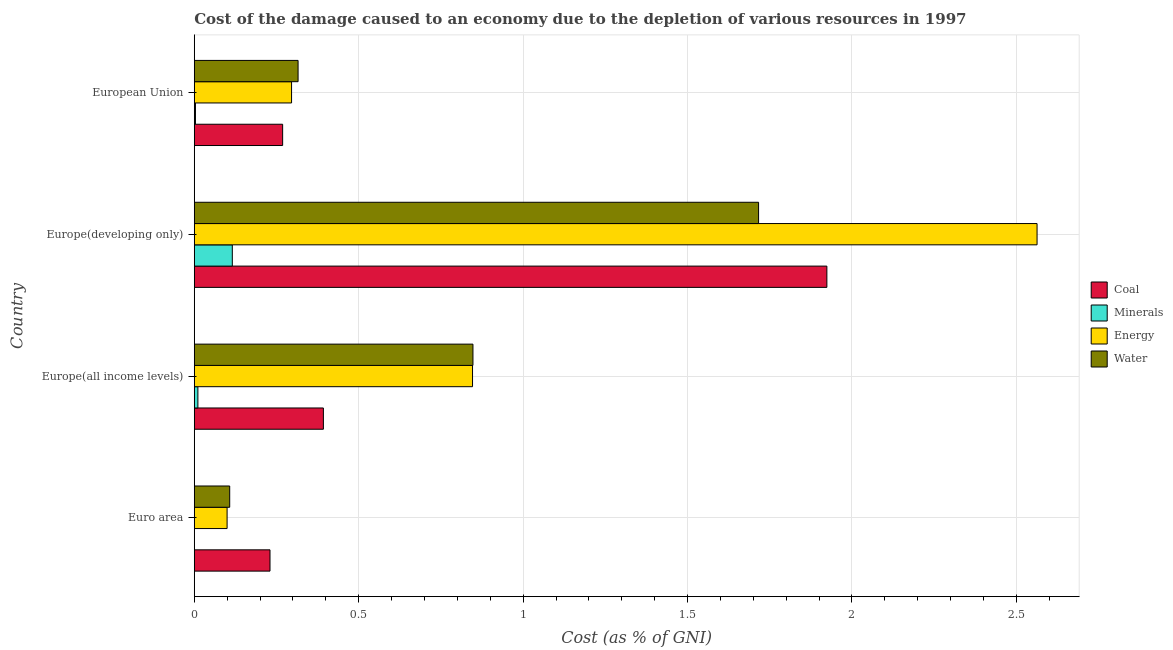How many bars are there on the 4th tick from the bottom?
Offer a terse response. 4. What is the label of the 1st group of bars from the top?
Give a very brief answer. European Union. What is the cost of damage due to depletion of water in Euro area?
Ensure brevity in your answer.  0.11. Across all countries, what is the maximum cost of damage due to depletion of energy?
Make the answer very short. 2.56. Across all countries, what is the minimum cost of damage due to depletion of coal?
Offer a very short reply. 0.23. In which country was the cost of damage due to depletion of energy maximum?
Make the answer very short. Europe(developing only). In which country was the cost of damage due to depletion of minerals minimum?
Your response must be concise. Euro area. What is the total cost of damage due to depletion of minerals in the graph?
Your answer should be very brief. 0.13. What is the difference between the cost of damage due to depletion of energy in Europe(developing only) and that in European Union?
Provide a short and direct response. 2.27. What is the difference between the cost of damage due to depletion of water in Euro area and the cost of damage due to depletion of coal in Europe(all income levels)?
Provide a short and direct response. -0.28. What is the average cost of damage due to depletion of coal per country?
Offer a terse response. 0.7. What is the difference between the cost of damage due to depletion of water and cost of damage due to depletion of coal in Europe(all income levels)?
Offer a terse response. 0.46. In how many countries, is the cost of damage due to depletion of water greater than 1.9 %?
Your answer should be very brief. 0. What is the ratio of the cost of damage due to depletion of water in Euro area to that in European Union?
Offer a terse response. 0.34. Is the difference between the cost of damage due to depletion of coal in Euro area and European Union greater than the difference between the cost of damage due to depletion of water in Euro area and European Union?
Keep it short and to the point. Yes. What is the difference between the highest and the second highest cost of damage due to depletion of water?
Provide a succinct answer. 0.87. What is the difference between the highest and the lowest cost of damage due to depletion of coal?
Offer a very short reply. 1.69. What does the 1st bar from the top in Europe(all income levels) represents?
Offer a very short reply. Water. What does the 1st bar from the bottom in European Union represents?
Provide a short and direct response. Coal. How many bars are there?
Give a very brief answer. 16. Are the values on the major ticks of X-axis written in scientific E-notation?
Provide a short and direct response. No. Does the graph contain any zero values?
Offer a terse response. No. How many legend labels are there?
Your answer should be very brief. 4. How are the legend labels stacked?
Give a very brief answer. Vertical. What is the title of the graph?
Your answer should be compact. Cost of the damage caused to an economy due to the depletion of various resources in 1997 . What is the label or title of the X-axis?
Your response must be concise. Cost (as % of GNI). What is the label or title of the Y-axis?
Provide a short and direct response. Country. What is the Cost (as % of GNI) of Coal in Euro area?
Give a very brief answer. 0.23. What is the Cost (as % of GNI) in Minerals in Euro area?
Keep it short and to the point. 0. What is the Cost (as % of GNI) of Energy in Euro area?
Make the answer very short. 0.1. What is the Cost (as % of GNI) of Water in Euro area?
Provide a short and direct response. 0.11. What is the Cost (as % of GNI) in Coal in Europe(all income levels)?
Provide a short and direct response. 0.39. What is the Cost (as % of GNI) of Minerals in Europe(all income levels)?
Provide a succinct answer. 0.01. What is the Cost (as % of GNI) in Energy in Europe(all income levels)?
Provide a short and direct response. 0.85. What is the Cost (as % of GNI) of Water in Europe(all income levels)?
Keep it short and to the point. 0.85. What is the Cost (as % of GNI) of Coal in Europe(developing only)?
Offer a terse response. 1.92. What is the Cost (as % of GNI) of Minerals in Europe(developing only)?
Provide a short and direct response. 0.12. What is the Cost (as % of GNI) in Energy in Europe(developing only)?
Offer a very short reply. 2.56. What is the Cost (as % of GNI) in Water in Europe(developing only)?
Your answer should be compact. 1.72. What is the Cost (as % of GNI) of Coal in European Union?
Your answer should be compact. 0.27. What is the Cost (as % of GNI) in Minerals in European Union?
Provide a short and direct response. 0. What is the Cost (as % of GNI) in Energy in European Union?
Offer a terse response. 0.3. What is the Cost (as % of GNI) in Water in European Union?
Provide a short and direct response. 0.32. Across all countries, what is the maximum Cost (as % of GNI) in Coal?
Your response must be concise. 1.92. Across all countries, what is the maximum Cost (as % of GNI) in Minerals?
Make the answer very short. 0.12. Across all countries, what is the maximum Cost (as % of GNI) of Energy?
Your answer should be compact. 2.56. Across all countries, what is the maximum Cost (as % of GNI) of Water?
Keep it short and to the point. 1.72. Across all countries, what is the minimum Cost (as % of GNI) in Coal?
Offer a very short reply. 0.23. Across all countries, what is the minimum Cost (as % of GNI) of Minerals?
Your answer should be compact. 0. Across all countries, what is the minimum Cost (as % of GNI) of Energy?
Keep it short and to the point. 0.1. Across all countries, what is the minimum Cost (as % of GNI) in Water?
Offer a very short reply. 0.11. What is the total Cost (as % of GNI) in Coal in the graph?
Your response must be concise. 2.82. What is the total Cost (as % of GNI) of Minerals in the graph?
Keep it short and to the point. 0.13. What is the total Cost (as % of GNI) in Energy in the graph?
Give a very brief answer. 3.8. What is the total Cost (as % of GNI) in Water in the graph?
Provide a short and direct response. 2.99. What is the difference between the Cost (as % of GNI) of Coal in Euro area and that in Europe(all income levels)?
Offer a very short reply. -0.16. What is the difference between the Cost (as % of GNI) in Minerals in Euro area and that in Europe(all income levels)?
Offer a terse response. -0.01. What is the difference between the Cost (as % of GNI) in Energy in Euro area and that in Europe(all income levels)?
Offer a terse response. -0.75. What is the difference between the Cost (as % of GNI) of Water in Euro area and that in Europe(all income levels)?
Your response must be concise. -0.74. What is the difference between the Cost (as % of GNI) of Coal in Euro area and that in Europe(developing only)?
Ensure brevity in your answer.  -1.69. What is the difference between the Cost (as % of GNI) of Minerals in Euro area and that in Europe(developing only)?
Give a very brief answer. -0.12. What is the difference between the Cost (as % of GNI) of Energy in Euro area and that in Europe(developing only)?
Keep it short and to the point. -2.46. What is the difference between the Cost (as % of GNI) in Water in Euro area and that in Europe(developing only)?
Your answer should be compact. -1.61. What is the difference between the Cost (as % of GNI) of Coal in Euro area and that in European Union?
Provide a succinct answer. -0.04. What is the difference between the Cost (as % of GNI) of Minerals in Euro area and that in European Union?
Provide a succinct answer. -0. What is the difference between the Cost (as % of GNI) in Energy in Euro area and that in European Union?
Offer a terse response. -0.2. What is the difference between the Cost (as % of GNI) of Water in Euro area and that in European Union?
Ensure brevity in your answer.  -0.21. What is the difference between the Cost (as % of GNI) of Coal in Europe(all income levels) and that in Europe(developing only)?
Your response must be concise. -1.53. What is the difference between the Cost (as % of GNI) of Minerals in Europe(all income levels) and that in Europe(developing only)?
Your answer should be compact. -0.1. What is the difference between the Cost (as % of GNI) of Energy in Europe(all income levels) and that in Europe(developing only)?
Your response must be concise. -1.72. What is the difference between the Cost (as % of GNI) in Water in Europe(all income levels) and that in Europe(developing only)?
Make the answer very short. -0.87. What is the difference between the Cost (as % of GNI) in Coal in Europe(all income levels) and that in European Union?
Offer a very short reply. 0.12. What is the difference between the Cost (as % of GNI) of Minerals in Europe(all income levels) and that in European Union?
Your response must be concise. 0.01. What is the difference between the Cost (as % of GNI) in Energy in Europe(all income levels) and that in European Union?
Your answer should be very brief. 0.55. What is the difference between the Cost (as % of GNI) in Water in Europe(all income levels) and that in European Union?
Ensure brevity in your answer.  0.53. What is the difference between the Cost (as % of GNI) of Coal in Europe(developing only) and that in European Union?
Your response must be concise. 1.66. What is the difference between the Cost (as % of GNI) in Minerals in Europe(developing only) and that in European Union?
Your answer should be very brief. 0.11. What is the difference between the Cost (as % of GNI) of Energy in Europe(developing only) and that in European Union?
Your answer should be compact. 2.27. What is the difference between the Cost (as % of GNI) of Water in Europe(developing only) and that in European Union?
Give a very brief answer. 1.4. What is the difference between the Cost (as % of GNI) in Coal in Euro area and the Cost (as % of GNI) in Minerals in Europe(all income levels)?
Give a very brief answer. 0.22. What is the difference between the Cost (as % of GNI) in Coal in Euro area and the Cost (as % of GNI) in Energy in Europe(all income levels)?
Your answer should be very brief. -0.62. What is the difference between the Cost (as % of GNI) of Coal in Euro area and the Cost (as % of GNI) of Water in Europe(all income levels)?
Make the answer very short. -0.62. What is the difference between the Cost (as % of GNI) in Minerals in Euro area and the Cost (as % of GNI) in Energy in Europe(all income levels)?
Your response must be concise. -0.85. What is the difference between the Cost (as % of GNI) of Minerals in Euro area and the Cost (as % of GNI) of Water in Europe(all income levels)?
Make the answer very short. -0.85. What is the difference between the Cost (as % of GNI) of Energy in Euro area and the Cost (as % of GNI) of Water in Europe(all income levels)?
Provide a succinct answer. -0.75. What is the difference between the Cost (as % of GNI) of Coal in Euro area and the Cost (as % of GNI) of Minerals in Europe(developing only)?
Your answer should be very brief. 0.11. What is the difference between the Cost (as % of GNI) in Coal in Euro area and the Cost (as % of GNI) in Energy in Europe(developing only)?
Provide a succinct answer. -2.33. What is the difference between the Cost (as % of GNI) in Coal in Euro area and the Cost (as % of GNI) in Water in Europe(developing only)?
Offer a very short reply. -1.49. What is the difference between the Cost (as % of GNI) in Minerals in Euro area and the Cost (as % of GNI) in Energy in Europe(developing only)?
Offer a very short reply. -2.56. What is the difference between the Cost (as % of GNI) of Minerals in Euro area and the Cost (as % of GNI) of Water in Europe(developing only)?
Your response must be concise. -1.72. What is the difference between the Cost (as % of GNI) in Energy in Euro area and the Cost (as % of GNI) in Water in Europe(developing only)?
Give a very brief answer. -1.62. What is the difference between the Cost (as % of GNI) of Coal in Euro area and the Cost (as % of GNI) of Minerals in European Union?
Give a very brief answer. 0.23. What is the difference between the Cost (as % of GNI) in Coal in Euro area and the Cost (as % of GNI) in Energy in European Union?
Your answer should be compact. -0.07. What is the difference between the Cost (as % of GNI) in Coal in Euro area and the Cost (as % of GNI) in Water in European Union?
Offer a terse response. -0.09. What is the difference between the Cost (as % of GNI) of Minerals in Euro area and the Cost (as % of GNI) of Energy in European Union?
Ensure brevity in your answer.  -0.3. What is the difference between the Cost (as % of GNI) of Minerals in Euro area and the Cost (as % of GNI) of Water in European Union?
Provide a succinct answer. -0.32. What is the difference between the Cost (as % of GNI) of Energy in Euro area and the Cost (as % of GNI) of Water in European Union?
Keep it short and to the point. -0.22. What is the difference between the Cost (as % of GNI) in Coal in Europe(all income levels) and the Cost (as % of GNI) in Minerals in Europe(developing only)?
Offer a terse response. 0.28. What is the difference between the Cost (as % of GNI) in Coal in Europe(all income levels) and the Cost (as % of GNI) in Energy in Europe(developing only)?
Keep it short and to the point. -2.17. What is the difference between the Cost (as % of GNI) in Coal in Europe(all income levels) and the Cost (as % of GNI) in Water in Europe(developing only)?
Make the answer very short. -1.32. What is the difference between the Cost (as % of GNI) in Minerals in Europe(all income levels) and the Cost (as % of GNI) in Energy in Europe(developing only)?
Offer a very short reply. -2.55. What is the difference between the Cost (as % of GNI) of Minerals in Europe(all income levels) and the Cost (as % of GNI) of Water in Europe(developing only)?
Ensure brevity in your answer.  -1.71. What is the difference between the Cost (as % of GNI) in Energy in Europe(all income levels) and the Cost (as % of GNI) in Water in Europe(developing only)?
Offer a very short reply. -0.87. What is the difference between the Cost (as % of GNI) in Coal in Europe(all income levels) and the Cost (as % of GNI) in Minerals in European Union?
Give a very brief answer. 0.39. What is the difference between the Cost (as % of GNI) in Coal in Europe(all income levels) and the Cost (as % of GNI) in Energy in European Union?
Offer a very short reply. 0.1. What is the difference between the Cost (as % of GNI) of Coal in Europe(all income levels) and the Cost (as % of GNI) of Water in European Union?
Provide a succinct answer. 0.08. What is the difference between the Cost (as % of GNI) of Minerals in Europe(all income levels) and the Cost (as % of GNI) of Energy in European Union?
Make the answer very short. -0.28. What is the difference between the Cost (as % of GNI) of Minerals in Europe(all income levels) and the Cost (as % of GNI) of Water in European Union?
Keep it short and to the point. -0.3. What is the difference between the Cost (as % of GNI) in Energy in Europe(all income levels) and the Cost (as % of GNI) in Water in European Union?
Keep it short and to the point. 0.53. What is the difference between the Cost (as % of GNI) in Coal in Europe(developing only) and the Cost (as % of GNI) in Minerals in European Union?
Ensure brevity in your answer.  1.92. What is the difference between the Cost (as % of GNI) of Coal in Europe(developing only) and the Cost (as % of GNI) of Energy in European Union?
Provide a succinct answer. 1.63. What is the difference between the Cost (as % of GNI) in Coal in Europe(developing only) and the Cost (as % of GNI) in Water in European Union?
Your response must be concise. 1.61. What is the difference between the Cost (as % of GNI) of Minerals in Europe(developing only) and the Cost (as % of GNI) of Energy in European Union?
Your response must be concise. -0.18. What is the difference between the Cost (as % of GNI) in Minerals in Europe(developing only) and the Cost (as % of GNI) in Water in European Union?
Give a very brief answer. -0.2. What is the difference between the Cost (as % of GNI) in Energy in Europe(developing only) and the Cost (as % of GNI) in Water in European Union?
Ensure brevity in your answer.  2.25. What is the average Cost (as % of GNI) in Coal per country?
Offer a very short reply. 0.7. What is the average Cost (as % of GNI) of Minerals per country?
Ensure brevity in your answer.  0.03. What is the average Cost (as % of GNI) in Energy per country?
Give a very brief answer. 0.95. What is the average Cost (as % of GNI) in Water per country?
Keep it short and to the point. 0.75. What is the difference between the Cost (as % of GNI) of Coal and Cost (as % of GNI) of Minerals in Euro area?
Your response must be concise. 0.23. What is the difference between the Cost (as % of GNI) of Coal and Cost (as % of GNI) of Energy in Euro area?
Ensure brevity in your answer.  0.13. What is the difference between the Cost (as % of GNI) in Coal and Cost (as % of GNI) in Water in Euro area?
Offer a very short reply. 0.12. What is the difference between the Cost (as % of GNI) of Minerals and Cost (as % of GNI) of Energy in Euro area?
Your answer should be compact. -0.1. What is the difference between the Cost (as % of GNI) of Minerals and Cost (as % of GNI) of Water in Euro area?
Your response must be concise. -0.11. What is the difference between the Cost (as % of GNI) in Energy and Cost (as % of GNI) in Water in Euro area?
Offer a terse response. -0.01. What is the difference between the Cost (as % of GNI) in Coal and Cost (as % of GNI) in Minerals in Europe(all income levels)?
Give a very brief answer. 0.38. What is the difference between the Cost (as % of GNI) in Coal and Cost (as % of GNI) in Energy in Europe(all income levels)?
Your answer should be very brief. -0.45. What is the difference between the Cost (as % of GNI) of Coal and Cost (as % of GNI) of Water in Europe(all income levels)?
Ensure brevity in your answer.  -0.45. What is the difference between the Cost (as % of GNI) in Minerals and Cost (as % of GNI) in Energy in Europe(all income levels)?
Your answer should be very brief. -0.84. What is the difference between the Cost (as % of GNI) in Minerals and Cost (as % of GNI) in Water in Europe(all income levels)?
Provide a succinct answer. -0.84. What is the difference between the Cost (as % of GNI) of Energy and Cost (as % of GNI) of Water in Europe(all income levels)?
Give a very brief answer. -0. What is the difference between the Cost (as % of GNI) in Coal and Cost (as % of GNI) in Minerals in Europe(developing only)?
Your answer should be compact. 1.81. What is the difference between the Cost (as % of GNI) of Coal and Cost (as % of GNI) of Energy in Europe(developing only)?
Your response must be concise. -0.64. What is the difference between the Cost (as % of GNI) in Coal and Cost (as % of GNI) in Water in Europe(developing only)?
Your answer should be very brief. 0.21. What is the difference between the Cost (as % of GNI) in Minerals and Cost (as % of GNI) in Energy in Europe(developing only)?
Provide a succinct answer. -2.45. What is the difference between the Cost (as % of GNI) in Minerals and Cost (as % of GNI) in Water in Europe(developing only)?
Your answer should be compact. -1.6. What is the difference between the Cost (as % of GNI) in Energy and Cost (as % of GNI) in Water in Europe(developing only)?
Provide a succinct answer. 0.85. What is the difference between the Cost (as % of GNI) of Coal and Cost (as % of GNI) of Minerals in European Union?
Ensure brevity in your answer.  0.27. What is the difference between the Cost (as % of GNI) of Coal and Cost (as % of GNI) of Energy in European Union?
Offer a terse response. -0.03. What is the difference between the Cost (as % of GNI) in Coal and Cost (as % of GNI) in Water in European Union?
Your answer should be very brief. -0.05. What is the difference between the Cost (as % of GNI) of Minerals and Cost (as % of GNI) of Energy in European Union?
Offer a terse response. -0.29. What is the difference between the Cost (as % of GNI) in Minerals and Cost (as % of GNI) in Water in European Union?
Provide a succinct answer. -0.31. What is the difference between the Cost (as % of GNI) of Energy and Cost (as % of GNI) of Water in European Union?
Your answer should be very brief. -0.02. What is the ratio of the Cost (as % of GNI) in Coal in Euro area to that in Europe(all income levels)?
Your response must be concise. 0.59. What is the ratio of the Cost (as % of GNI) in Minerals in Euro area to that in Europe(all income levels)?
Offer a terse response. 0.03. What is the ratio of the Cost (as % of GNI) in Energy in Euro area to that in Europe(all income levels)?
Your answer should be compact. 0.12. What is the ratio of the Cost (as % of GNI) of Water in Euro area to that in Europe(all income levels)?
Provide a succinct answer. 0.13. What is the ratio of the Cost (as % of GNI) of Coal in Euro area to that in Europe(developing only)?
Keep it short and to the point. 0.12. What is the ratio of the Cost (as % of GNI) in Minerals in Euro area to that in Europe(developing only)?
Keep it short and to the point. 0. What is the ratio of the Cost (as % of GNI) in Energy in Euro area to that in Europe(developing only)?
Provide a short and direct response. 0.04. What is the ratio of the Cost (as % of GNI) in Water in Euro area to that in Europe(developing only)?
Offer a very short reply. 0.06. What is the ratio of the Cost (as % of GNI) of Coal in Euro area to that in European Union?
Offer a terse response. 0.86. What is the ratio of the Cost (as % of GNI) of Minerals in Euro area to that in European Union?
Offer a very short reply. 0.1. What is the ratio of the Cost (as % of GNI) in Energy in Euro area to that in European Union?
Offer a terse response. 0.34. What is the ratio of the Cost (as % of GNI) in Water in Euro area to that in European Union?
Make the answer very short. 0.34. What is the ratio of the Cost (as % of GNI) in Coal in Europe(all income levels) to that in Europe(developing only)?
Offer a very short reply. 0.2. What is the ratio of the Cost (as % of GNI) in Minerals in Europe(all income levels) to that in Europe(developing only)?
Your answer should be very brief. 0.1. What is the ratio of the Cost (as % of GNI) in Energy in Europe(all income levels) to that in Europe(developing only)?
Provide a succinct answer. 0.33. What is the ratio of the Cost (as % of GNI) in Water in Europe(all income levels) to that in Europe(developing only)?
Keep it short and to the point. 0.49. What is the ratio of the Cost (as % of GNI) in Coal in Europe(all income levels) to that in European Union?
Offer a very short reply. 1.46. What is the ratio of the Cost (as % of GNI) in Minerals in Europe(all income levels) to that in European Union?
Give a very brief answer. 3.03. What is the ratio of the Cost (as % of GNI) in Energy in Europe(all income levels) to that in European Union?
Your answer should be compact. 2.86. What is the ratio of the Cost (as % of GNI) of Water in Europe(all income levels) to that in European Union?
Make the answer very short. 2.68. What is the ratio of the Cost (as % of GNI) of Coal in Europe(developing only) to that in European Union?
Give a very brief answer. 7.16. What is the ratio of the Cost (as % of GNI) of Minerals in Europe(developing only) to that in European Union?
Your answer should be compact. 31.75. What is the ratio of the Cost (as % of GNI) of Energy in Europe(developing only) to that in European Union?
Offer a terse response. 8.66. What is the ratio of the Cost (as % of GNI) of Water in Europe(developing only) to that in European Union?
Your answer should be compact. 5.44. What is the difference between the highest and the second highest Cost (as % of GNI) of Coal?
Provide a succinct answer. 1.53. What is the difference between the highest and the second highest Cost (as % of GNI) in Minerals?
Keep it short and to the point. 0.1. What is the difference between the highest and the second highest Cost (as % of GNI) of Energy?
Provide a short and direct response. 1.72. What is the difference between the highest and the second highest Cost (as % of GNI) in Water?
Keep it short and to the point. 0.87. What is the difference between the highest and the lowest Cost (as % of GNI) of Coal?
Ensure brevity in your answer.  1.69. What is the difference between the highest and the lowest Cost (as % of GNI) of Minerals?
Your answer should be compact. 0.12. What is the difference between the highest and the lowest Cost (as % of GNI) of Energy?
Keep it short and to the point. 2.46. What is the difference between the highest and the lowest Cost (as % of GNI) of Water?
Your response must be concise. 1.61. 